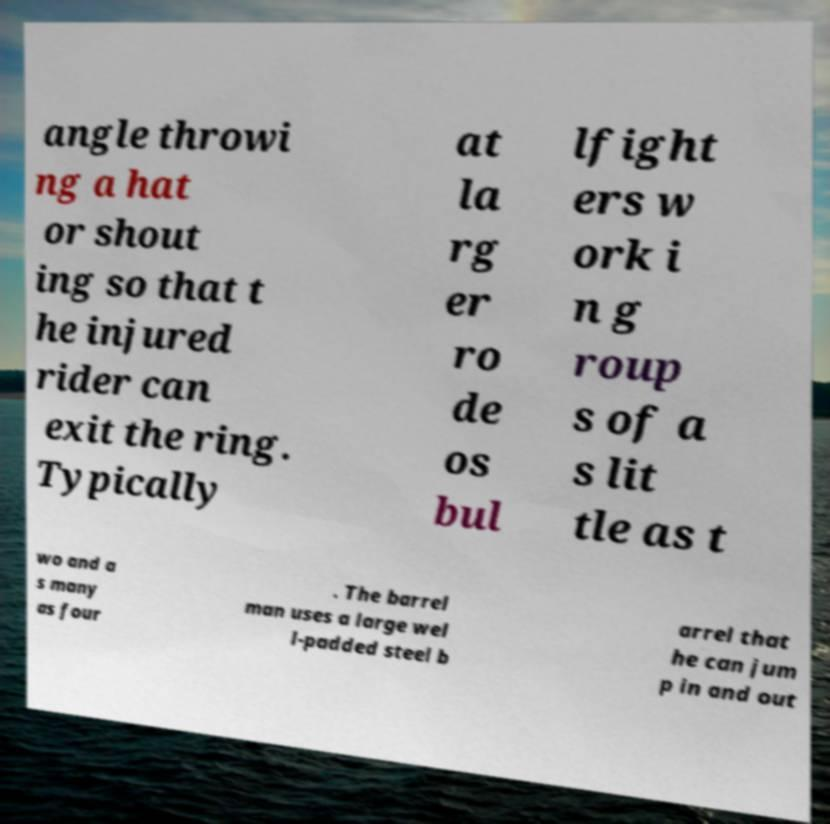There's text embedded in this image that I need extracted. Can you transcribe it verbatim? angle throwi ng a hat or shout ing so that t he injured rider can exit the ring. Typically at la rg er ro de os bul lfight ers w ork i n g roup s of a s lit tle as t wo and a s many as four . The barrel man uses a large wel l-padded steel b arrel that he can jum p in and out 